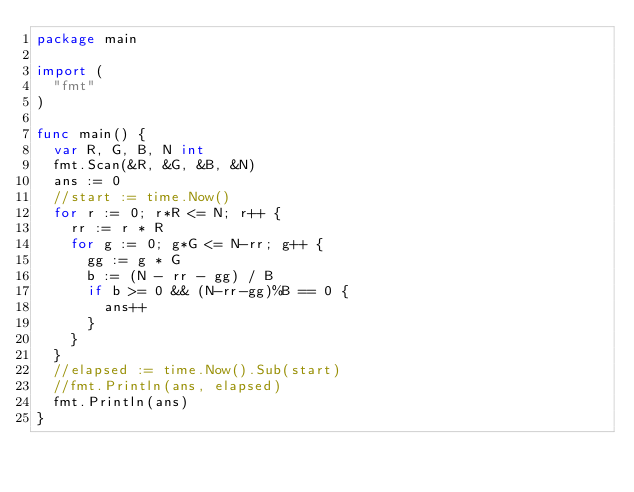Convert code to text. <code><loc_0><loc_0><loc_500><loc_500><_Go_>package main

import (
	"fmt"
)

func main() {
	var R, G, B, N int
	fmt.Scan(&R, &G, &B, &N)
	ans := 0
	//start := time.Now()
	for r := 0; r*R <= N; r++ {
		rr := r * R
		for g := 0; g*G <= N-rr; g++ {
			gg := g * G
			b := (N - rr - gg) / B
			if b >= 0 && (N-rr-gg)%B == 0 {
				ans++
			}
		}
	}
	//elapsed := time.Now().Sub(start)
	//fmt.Println(ans, elapsed)
	fmt.Println(ans)
}
</code> 